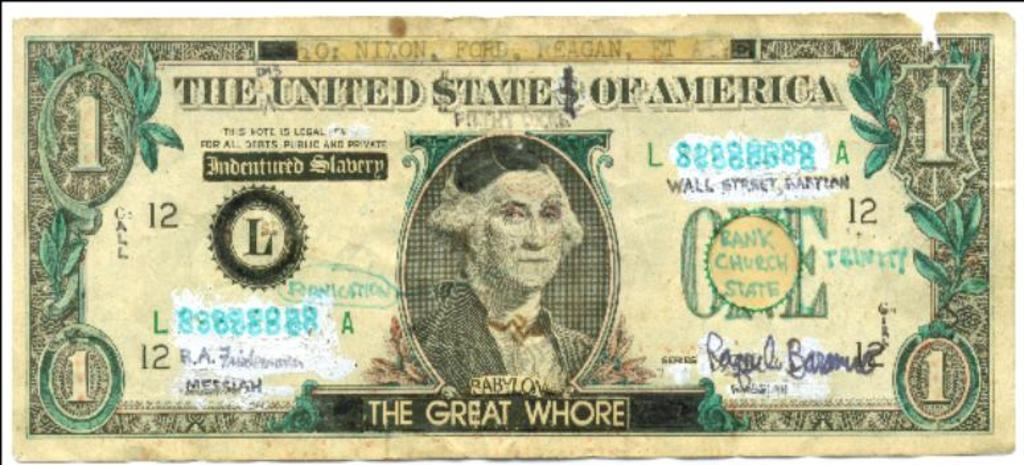<image>
Present a compact description of the photo's key features. a United States dollar bill with the word whore on it 